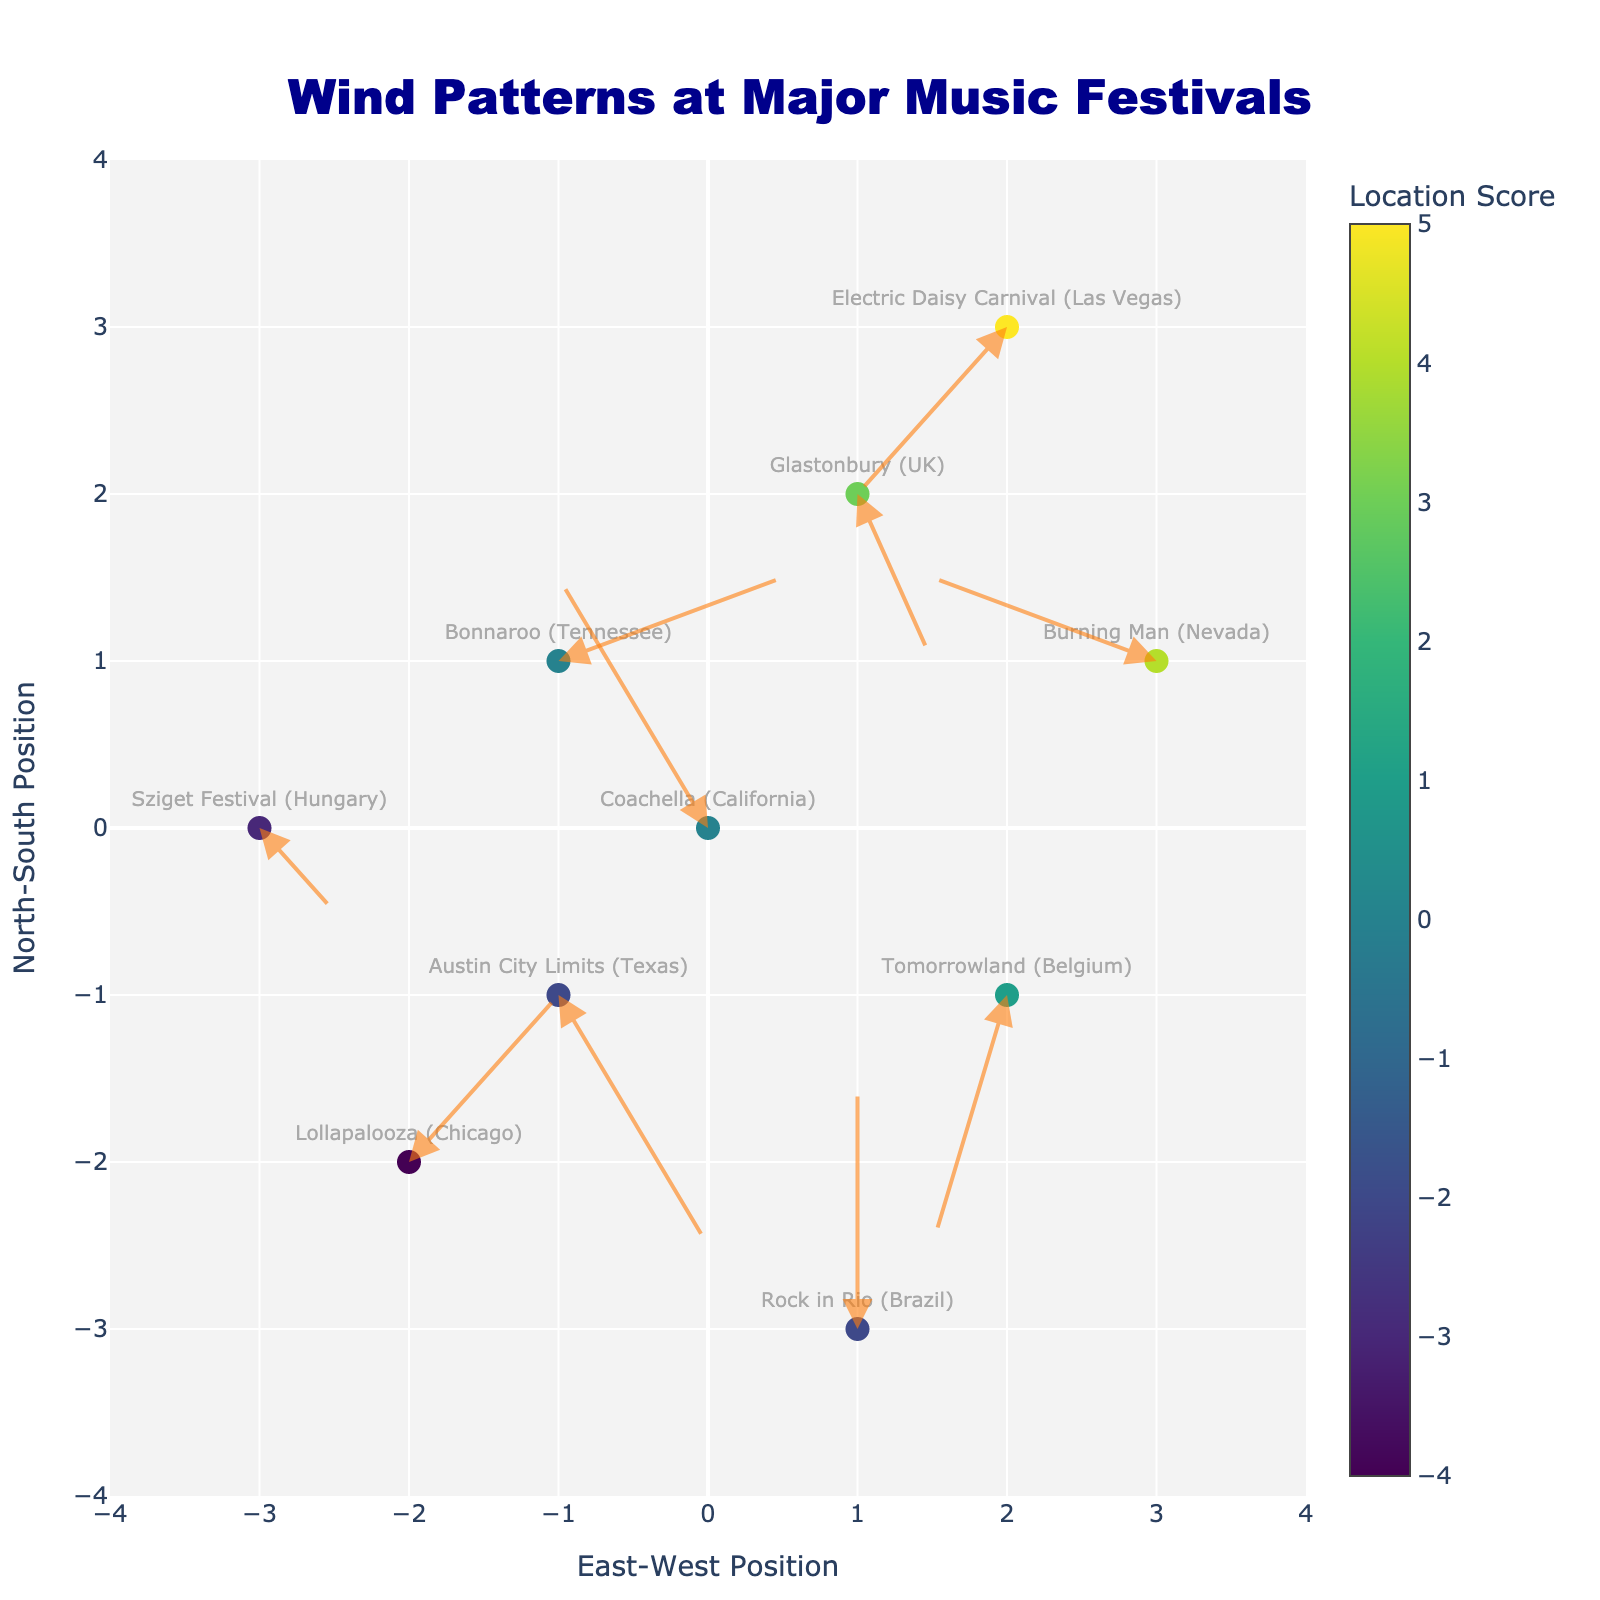How many music festival locations are represented in the figure? Count the number of markers with text labels denoting each location on the plot. There should be 10 text labels.
Answer: 10 What are the x and y ranges of this plot? The x-axis and y-axis limits are both set to a range of -4 to 4 as indicated by the axis ticks and labels.
Answer: -4 to 4 Which location shows the largest northward (positive y) wind pattern? Look for the longest arrow pointing upward. The arrow with the largest positive change in y (v) is at Coachella (California) with v = 3.
Answer: Coachella (California) What is the average east-west (u) wind vector component for locations with positive y positions? Identify locations with positive y positions (Glastonbury, Bonnaroo, Electric Daisy Carnival) and calculate the average of their u components: (1 + 3 - 2)/3 = 2/3 ≈ 0.67.
Answer: ≈ 0.67 Which location has the most significant westward (negative x) wind vector component? Look for the arrow with the largest negative u component. Burning Man (Nevada) shows u = -3, the most significant westward change.
Answer: Burning Man (Nevada) What is the wind pattern direction of Sziget Festival (Hungary)? The wind vector components u and v for Sziget Festival (Hungary) are 1 and -1, indicating a southeast direction.
Answer: Southeast Which locations have no wind speed in the east-west direction (u = 0)? Look for vectors with no horizontal component. Rock in Rio (Brazil) has u = 0.
Answer: Rock in Rio (Brazil) How does the wind pattern at Lollapalooza (Chicago) compare to Tomorrowland (Belgium)? Lollapalooza has wind vectors (u=2, v=2), indicating an equal northeastward direction, while Tomorrowland has (u=-1, v=-3), indicating a southwestward direction. Lollapalooza winds are strong and north-easterly, while Tomorrowland winds are strong and southwesterly.
Answer: Lollapalooza: northeast, Tomorrowland: southwest What is the total distance covered by the wind vector at Austin City Limits (Texas)? Calculate the magnitude of the vector (u=2, v=-3) using the Pythagorean theorem: sqrt(2^2 + (-3)^2) = sqrt(4 + 9) = sqrt(13) ≈ 3.61.
Answer: ≈ 3.61 Which festivals are located at negative x and y coordinates? Identify markers with both x and y negative: Lollapalooza (Chicago) and Austin City Limits (Texas).
Answer: Lollapalooza, Austin City Limits 